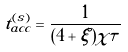<formula> <loc_0><loc_0><loc_500><loc_500>t _ { a c c } ^ { ( s ) } = \frac { 1 } { ( 4 + \xi ) \chi \tau }</formula> 